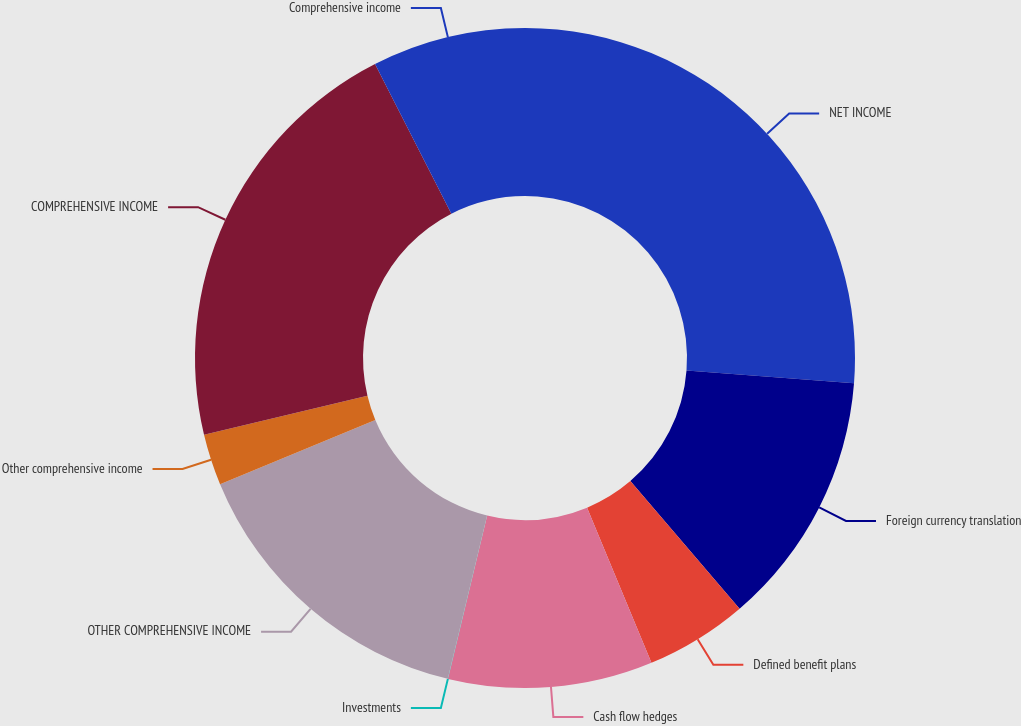<chart> <loc_0><loc_0><loc_500><loc_500><pie_chart><fcel>NET INCOME<fcel>Foreign currency translation<fcel>Defined benefit plans<fcel>Cash flow hedges<fcel>Investments<fcel>OTHER COMPREHENSIVE INCOME<fcel>Other comprehensive income<fcel>COMPREHENSIVE INCOME<fcel>Comprehensive income<nl><fcel>26.23%<fcel>12.51%<fcel>5.01%<fcel>10.01%<fcel>0.01%<fcel>15.0%<fcel>2.51%<fcel>21.23%<fcel>7.51%<nl></chart> 